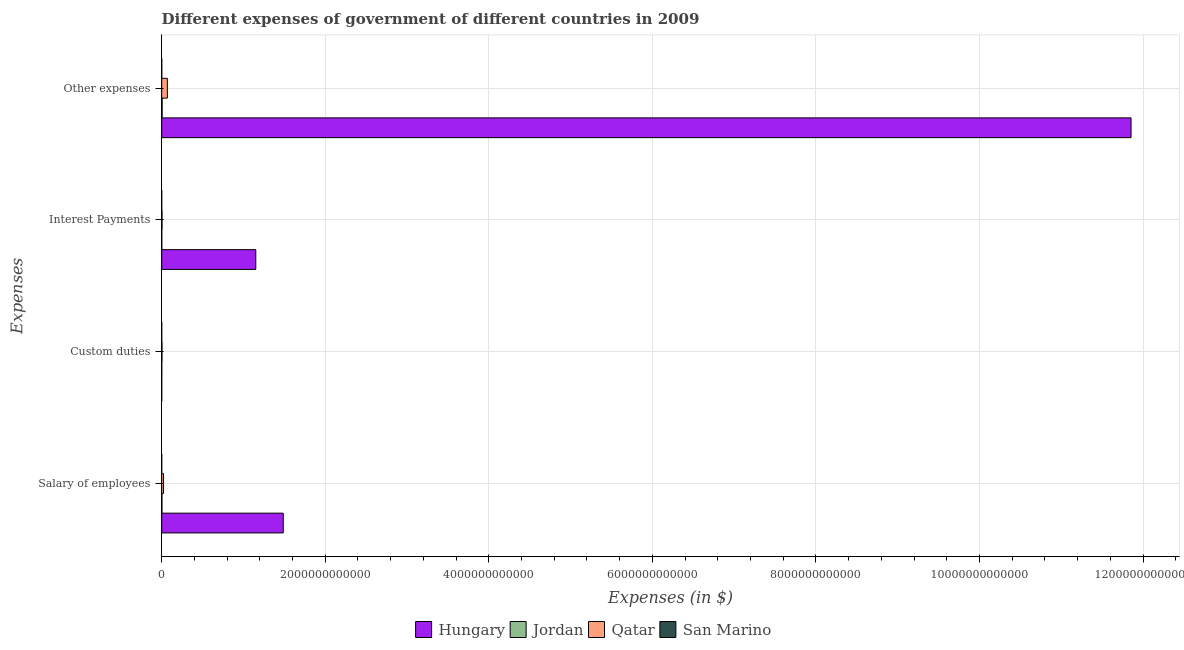How many groups of bars are there?
Provide a short and direct response. 4. How many bars are there on the 4th tick from the top?
Ensure brevity in your answer.  4. What is the label of the 1st group of bars from the top?
Your response must be concise. Other expenses. What is the amount spent on custom duties in Jordan?
Your answer should be very brief. 2.70e+08. Across all countries, what is the maximum amount spent on interest payments?
Your answer should be very brief. 1.15e+12. Across all countries, what is the minimum amount spent on other expenses?
Offer a terse response. 5.34e+08. In which country was the amount spent on interest payments maximum?
Offer a terse response. Hungary. What is the total amount spent on interest payments in the graph?
Your response must be concise. 1.15e+12. What is the difference between the amount spent on salary of employees in San Marino and that in Jordan?
Your answer should be very brief. -2.36e+09. What is the difference between the amount spent on custom duties in San Marino and the amount spent on other expenses in Hungary?
Give a very brief answer. -1.19e+13. What is the average amount spent on other expenses per country?
Your answer should be compact. 2.98e+12. What is the difference between the amount spent on custom duties and amount spent on interest payments in San Marino?
Your answer should be very brief. -2.53e+06. What is the ratio of the amount spent on other expenses in Qatar to that in San Marino?
Your answer should be very brief. 129.28. Is the difference between the amount spent on interest payments in Jordan and San Marino greater than the difference between the amount spent on salary of employees in Jordan and San Marino?
Give a very brief answer. No. What is the difference between the highest and the second highest amount spent on custom duties?
Provide a succinct answer. 2.84e+09. What is the difference between the highest and the lowest amount spent on interest payments?
Your answer should be very brief. 1.15e+12. In how many countries, is the amount spent on other expenses greater than the average amount spent on other expenses taken over all countries?
Offer a terse response. 1. Is it the case that in every country, the sum of the amount spent on salary of employees and amount spent on custom duties is greater than the amount spent on interest payments?
Offer a very short reply. Yes. Are all the bars in the graph horizontal?
Provide a succinct answer. Yes. What is the difference between two consecutive major ticks on the X-axis?
Provide a succinct answer. 2.00e+12. Does the graph contain grids?
Your response must be concise. Yes. Where does the legend appear in the graph?
Give a very brief answer. Bottom center. How many legend labels are there?
Provide a short and direct response. 4. What is the title of the graph?
Provide a succinct answer. Different expenses of government of different countries in 2009. Does "Lebanon" appear as one of the legend labels in the graph?
Keep it short and to the point. No. What is the label or title of the X-axis?
Your answer should be compact. Expenses (in $). What is the label or title of the Y-axis?
Give a very brief answer. Expenses. What is the Expenses (in $) of Hungary in Salary of employees?
Provide a short and direct response. 1.49e+12. What is the Expenses (in $) of Jordan in Salary of employees?
Give a very brief answer. 2.53e+09. What is the Expenses (in $) in Qatar in Salary of employees?
Ensure brevity in your answer.  2.24e+1. What is the Expenses (in $) of San Marino in Salary of employees?
Ensure brevity in your answer.  1.77e+08. What is the Expenses (in $) in Hungary in Custom duties?
Make the answer very short. 0. What is the Expenses (in $) of Jordan in Custom duties?
Make the answer very short. 2.70e+08. What is the Expenses (in $) of Qatar in Custom duties?
Offer a terse response. 3.11e+09. What is the Expenses (in $) of San Marino in Custom duties?
Offer a terse response. 3.91e+06. What is the Expenses (in $) in Hungary in Interest Payments?
Your answer should be compact. 1.15e+12. What is the Expenses (in $) in Jordan in Interest Payments?
Provide a short and direct response. 3.92e+08. What is the Expenses (in $) of Qatar in Interest Payments?
Keep it short and to the point. 3.60e+09. What is the Expenses (in $) in San Marino in Interest Payments?
Provide a short and direct response. 6.45e+06. What is the Expenses (in $) of Hungary in Other expenses?
Your response must be concise. 1.19e+13. What is the Expenses (in $) in Jordan in Other expenses?
Provide a short and direct response. 5.09e+09. What is the Expenses (in $) in Qatar in Other expenses?
Your answer should be compact. 6.90e+1. What is the Expenses (in $) of San Marino in Other expenses?
Your answer should be very brief. 5.34e+08. Across all Expenses, what is the maximum Expenses (in $) in Hungary?
Offer a very short reply. 1.19e+13. Across all Expenses, what is the maximum Expenses (in $) of Jordan?
Make the answer very short. 5.09e+09. Across all Expenses, what is the maximum Expenses (in $) of Qatar?
Provide a short and direct response. 6.90e+1. Across all Expenses, what is the maximum Expenses (in $) in San Marino?
Your answer should be compact. 5.34e+08. Across all Expenses, what is the minimum Expenses (in $) in Jordan?
Your answer should be very brief. 2.70e+08. Across all Expenses, what is the minimum Expenses (in $) in Qatar?
Provide a short and direct response. 3.11e+09. Across all Expenses, what is the minimum Expenses (in $) in San Marino?
Provide a succinct answer. 3.91e+06. What is the total Expenses (in $) in Hungary in the graph?
Make the answer very short. 1.45e+13. What is the total Expenses (in $) in Jordan in the graph?
Offer a terse response. 8.29e+09. What is the total Expenses (in $) in Qatar in the graph?
Make the answer very short. 9.81e+1. What is the total Expenses (in $) in San Marino in the graph?
Offer a very short reply. 7.21e+08. What is the difference between the Expenses (in $) of Jordan in Salary of employees and that in Custom duties?
Offer a very short reply. 2.26e+09. What is the difference between the Expenses (in $) in Qatar in Salary of employees and that in Custom duties?
Keep it short and to the point. 1.93e+1. What is the difference between the Expenses (in $) of San Marino in Salary of employees and that in Custom duties?
Keep it short and to the point. 1.73e+08. What is the difference between the Expenses (in $) in Hungary in Salary of employees and that in Interest Payments?
Your response must be concise. 3.35e+11. What is the difference between the Expenses (in $) of Jordan in Salary of employees and that in Interest Payments?
Your answer should be compact. 2.14e+09. What is the difference between the Expenses (in $) in Qatar in Salary of employees and that in Interest Payments?
Give a very brief answer. 1.88e+1. What is the difference between the Expenses (in $) in San Marino in Salary of employees and that in Interest Payments?
Ensure brevity in your answer.  1.71e+08. What is the difference between the Expenses (in $) of Hungary in Salary of employees and that in Other expenses?
Your answer should be compact. -1.04e+13. What is the difference between the Expenses (in $) in Jordan in Salary of employees and that in Other expenses?
Ensure brevity in your answer.  -2.56e+09. What is the difference between the Expenses (in $) in Qatar in Salary of employees and that in Other expenses?
Offer a very short reply. -4.66e+1. What is the difference between the Expenses (in $) in San Marino in Salary of employees and that in Other expenses?
Keep it short and to the point. -3.57e+08. What is the difference between the Expenses (in $) in Jordan in Custom duties and that in Interest Payments?
Provide a succinct answer. -1.22e+08. What is the difference between the Expenses (in $) of Qatar in Custom duties and that in Interest Payments?
Offer a terse response. -4.85e+08. What is the difference between the Expenses (in $) of San Marino in Custom duties and that in Interest Payments?
Make the answer very short. -2.53e+06. What is the difference between the Expenses (in $) in Jordan in Custom duties and that in Other expenses?
Provide a short and direct response. -4.82e+09. What is the difference between the Expenses (in $) of Qatar in Custom duties and that in Other expenses?
Keep it short and to the point. -6.59e+1. What is the difference between the Expenses (in $) of San Marino in Custom duties and that in Other expenses?
Make the answer very short. -5.30e+08. What is the difference between the Expenses (in $) of Hungary in Interest Payments and that in Other expenses?
Your response must be concise. -1.07e+13. What is the difference between the Expenses (in $) of Jordan in Interest Payments and that in Other expenses?
Offer a terse response. -4.70e+09. What is the difference between the Expenses (in $) of Qatar in Interest Payments and that in Other expenses?
Your response must be concise. -6.54e+1. What is the difference between the Expenses (in $) in San Marino in Interest Payments and that in Other expenses?
Ensure brevity in your answer.  -5.27e+08. What is the difference between the Expenses (in $) of Hungary in Salary of employees and the Expenses (in $) of Jordan in Custom duties?
Your answer should be compact. 1.49e+12. What is the difference between the Expenses (in $) in Hungary in Salary of employees and the Expenses (in $) in Qatar in Custom duties?
Offer a very short reply. 1.48e+12. What is the difference between the Expenses (in $) of Hungary in Salary of employees and the Expenses (in $) of San Marino in Custom duties?
Your answer should be compact. 1.49e+12. What is the difference between the Expenses (in $) in Jordan in Salary of employees and the Expenses (in $) in Qatar in Custom duties?
Ensure brevity in your answer.  -5.81e+08. What is the difference between the Expenses (in $) in Jordan in Salary of employees and the Expenses (in $) in San Marino in Custom duties?
Give a very brief answer. 2.53e+09. What is the difference between the Expenses (in $) of Qatar in Salary of employees and the Expenses (in $) of San Marino in Custom duties?
Give a very brief answer. 2.24e+1. What is the difference between the Expenses (in $) in Hungary in Salary of employees and the Expenses (in $) in Jordan in Interest Payments?
Keep it short and to the point. 1.49e+12. What is the difference between the Expenses (in $) in Hungary in Salary of employees and the Expenses (in $) in Qatar in Interest Payments?
Your answer should be very brief. 1.48e+12. What is the difference between the Expenses (in $) of Hungary in Salary of employees and the Expenses (in $) of San Marino in Interest Payments?
Offer a terse response. 1.49e+12. What is the difference between the Expenses (in $) of Jordan in Salary of employees and the Expenses (in $) of Qatar in Interest Payments?
Keep it short and to the point. -1.07e+09. What is the difference between the Expenses (in $) in Jordan in Salary of employees and the Expenses (in $) in San Marino in Interest Payments?
Your answer should be very brief. 2.53e+09. What is the difference between the Expenses (in $) of Qatar in Salary of employees and the Expenses (in $) of San Marino in Interest Payments?
Keep it short and to the point. 2.24e+1. What is the difference between the Expenses (in $) of Hungary in Salary of employees and the Expenses (in $) of Jordan in Other expenses?
Your response must be concise. 1.48e+12. What is the difference between the Expenses (in $) of Hungary in Salary of employees and the Expenses (in $) of Qatar in Other expenses?
Your answer should be very brief. 1.42e+12. What is the difference between the Expenses (in $) of Hungary in Salary of employees and the Expenses (in $) of San Marino in Other expenses?
Keep it short and to the point. 1.49e+12. What is the difference between the Expenses (in $) of Jordan in Salary of employees and the Expenses (in $) of Qatar in Other expenses?
Give a very brief answer. -6.65e+1. What is the difference between the Expenses (in $) in Jordan in Salary of employees and the Expenses (in $) in San Marino in Other expenses?
Your response must be concise. 2.00e+09. What is the difference between the Expenses (in $) in Qatar in Salary of employees and the Expenses (in $) in San Marino in Other expenses?
Offer a very short reply. 2.18e+1. What is the difference between the Expenses (in $) in Jordan in Custom duties and the Expenses (in $) in Qatar in Interest Payments?
Offer a terse response. -3.33e+09. What is the difference between the Expenses (in $) in Jordan in Custom duties and the Expenses (in $) in San Marino in Interest Payments?
Make the answer very short. 2.64e+08. What is the difference between the Expenses (in $) of Qatar in Custom duties and the Expenses (in $) of San Marino in Interest Payments?
Ensure brevity in your answer.  3.11e+09. What is the difference between the Expenses (in $) in Jordan in Custom duties and the Expenses (in $) in Qatar in Other expenses?
Your answer should be compact. -6.87e+1. What is the difference between the Expenses (in $) in Jordan in Custom duties and the Expenses (in $) in San Marino in Other expenses?
Keep it short and to the point. -2.64e+08. What is the difference between the Expenses (in $) in Qatar in Custom duties and the Expenses (in $) in San Marino in Other expenses?
Provide a succinct answer. 2.58e+09. What is the difference between the Expenses (in $) in Hungary in Interest Payments and the Expenses (in $) in Jordan in Other expenses?
Ensure brevity in your answer.  1.15e+12. What is the difference between the Expenses (in $) in Hungary in Interest Payments and the Expenses (in $) in Qatar in Other expenses?
Keep it short and to the point. 1.08e+12. What is the difference between the Expenses (in $) in Hungary in Interest Payments and the Expenses (in $) in San Marino in Other expenses?
Keep it short and to the point. 1.15e+12. What is the difference between the Expenses (in $) in Jordan in Interest Payments and the Expenses (in $) in Qatar in Other expenses?
Your answer should be very brief. -6.86e+1. What is the difference between the Expenses (in $) of Jordan in Interest Payments and the Expenses (in $) of San Marino in Other expenses?
Offer a terse response. -1.42e+08. What is the difference between the Expenses (in $) in Qatar in Interest Payments and the Expenses (in $) in San Marino in Other expenses?
Ensure brevity in your answer.  3.07e+09. What is the average Expenses (in $) in Hungary per Expenses?
Your response must be concise. 3.62e+12. What is the average Expenses (in $) in Jordan per Expenses?
Provide a succinct answer. 2.07e+09. What is the average Expenses (in $) in Qatar per Expenses?
Ensure brevity in your answer.  2.45e+1. What is the average Expenses (in $) in San Marino per Expenses?
Give a very brief answer. 1.80e+08. What is the difference between the Expenses (in $) in Hungary and Expenses (in $) in Jordan in Salary of employees?
Provide a succinct answer. 1.48e+12. What is the difference between the Expenses (in $) in Hungary and Expenses (in $) in Qatar in Salary of employees?
Keep it short and to the point. 1.46e+12. What is the difference between the Expenses (in $) of Hungary and Expenses (in $) of San Marino in Salary of employees?
Offer a terse response. 1.49e+12. What is the difference between the Expenses (in $) in Jordan and Expenses (in $) in Qatar in Salary of employees?
Your answer should be very brief. -1.99e+1. What is the difference between the Expenses (in $) of Jordan and Expenses (in $) of San Marino in Salary of employees?
Offer a very short reply. 2.36e+09. What is the difference between the Expenses (in $) of Qatar and Expenses (in $) of San Marino in Salary of employees?
Your answer should be compact. 2.22e+1. What is the difference between the Expenses (in $) of Jordan and Expenses (in $) of Qatar in Custom duties?
Offer a very short reply. -2.84e+09. What is the difference between the Expenses (in $) in Jordan and Expenses (in $) in San Marino in Custom duties?
Keep it short and to the point. 2.66e+08. What is the difference between the Expenses (in $) of Qatar and Expenses (in $) of San Marino in Custom duties?
Keep it short and to the point. 3.11e+09. What is the difference between the Expenses (in $) of Hungary and Expenses (in $) of Jordan in Interest Payments?
Provide a succinct answer. 1.15e+12. What is the difference between the Expenses (in $) in Hungary and Expenses (in $) in Qatar in Interest Payments?
Offer a terse response. 1.15e+12. What is the difference between the Expenses (in $) in Hungary and Expenses (in $) in San Marino in Interest Payments?
Keep it short and to the point. 1.15e+12. What is the difference between the Expenses (in $) in Jordan and Expenses (in $) in Qatar in Interest Payments?
Offer a terse response. -3.21e+09. What is the difference between the Expenses (in $) in Jordan and Expenses (in $) in San Marino in Interest Payments?
Your response must be concise. 3.86e+08. What is the difference between the Expenses (in $) of Qatar and Expenses (in $) of San Marino in Interest Payments?
Your response must be concise. 3.59e+09. What is the difference between the Expenses (in $) of Hungary and Expenses (in $) of Jordan in Other expenses?
Make the answer very short. 1.18e+13. What is the difference between the Expenses (in $) in Hungary and Expenses (in $) in Qatar in Other expenses?
Offer a very short reply. 1.18e+13. What is the difference between the Expenses (in $) of Hungary and Expenses (in $) of San Marino in Other expenses?
Keep it short and to the point. 1.19e+13. What is the difference between the Expenses (in $) in Jordan and Expenses (in $) in Qatar in Other expenses?
Your answer should be very brief. -6.39e+1. What is the difference between the Expenses (in $) of Jordan and Expenses (in $) of San Marino in Other expenses?
Your response must be concise. 4.56e+09. What is the difference between the Expenses (in $) in Qatar and Expenses (in $) in San Marino in Other expenses?
Provide a succinct answer. 6.85e+1. What is the ratio of the Expenses (in $) in Jordan in Salary of employees to that in Custom duties?
Your response must be concise. 9.37. What is the ratio of the Expenses (in $) in Qatar in Salary of employees to that in Custom duties?
Ensure brevity in your answer.  7.19. What is the ratio of the Expenses (in $) of San Marino in Salary of employees to that in Custom duties?
Offer a terse response. 45.28. What is the ratio of the Expenses (in $) in Hungary in Salary of employees to that in Interest Payments?
Offer a very short reply. 1.29. What is the ratio of the Expenses (in $) of Jordan in Salary of employees to that in Interest Payments?
Offer a terse response. 6.46. What is the ratio of the Expenses (in $) of Qatar in Salary of employees to that in Interest Payments?
Your answer should be very brief. 6.22. What is the ratio of the Expenses (in $) of San Marino in Salary of employees to that in Interest Payments?
Offer a very short reply. 27.49. What is the ratio of the Expenses (in $) of Hungary in Salary of employees to that in Other expenses?
Your answer should be compact. 0.13. What is the ratio of the Expenses (in $) in Jordan in Salary of employees to that in Other expenses?
Ensure brevity in your answer.  0.5. What is the ratio of the Expenses (in $) in Qatar in Salary of employees to that in Other expenses?
Provide a succinct answer. 0.32. What is the ratio of the Expenses (in $) of San Marino in Salary of employees to that in Other expenses?
Provide a short and direct response. 0.33. What is the ratio of the Expenses (in $) of Jordan in Custom duties to that in Interest Payments?
Make the answer very short. 0.69. What is the ratio of the Expenses (in $) in Qatar in Custom duties to that in Interest Payments?
Provide a succinct answer. 0.87. What is the ratio of the Expenses (in $) in San Marino in Custom duties to that in Interest Payments?
Ensure brevity in your answer.  0.61. What is the ratio of the Expenses (in $) of Jordan in Custom duties to that in Other expenses?
Your response must be concise. 0.05. What is the ratio of the Expenses (in $) in Qatar in Custom duties to that in Other expenses?
Your answer should be compact. 0.05. What is the ratio of the Expenses (in $) in San Marino in Custom duties to that in Other expenses?
Your response must be concise. 0.01. What is the ratio of the Expenses (in $) in Hungary in Interest Payments to that in Other expenses?
Your answer should be compact. 0.1. What is the ratio of the Expenses (in $) in Jordan in Interest Payments to that in Other expenses?
Offer a terse response. 0.08. What is the ratio of the Expenses (in $) in Qatar in Interest Payments to that in Other expenses?
Your response must be concise. 0.05. What is the ratio of the Expenses (in $) of San Marino in Interest Payments to that in Other expenses?
Provide a succinct answer. 0.01. What is the difference between the highest and the second highest Expenses (in $) in Hungary?
Offer a very short reply. 1.04e+13. What is the difference between the highest and the second highest Expenses (in $) in Jordan?
Make the answer very short. 2.56e+09. What is the difference between the highest and the second highest Expenses (in $) of Qatar?
Your answer should be compact. 4.66e+1. What is the difference between the highest and the second highest Expenses (in $) in San Marino?
Offer a very short reply. 3.57e+08. What is the difference between the highest and the lowest Expenses (in $) in Hungary?
Offer a very short reply. 1.19e+13. What is the difference between the highest and the lowest Expenses (in $) of Jordan?
Your answer should be compact. 4.82e+09. What is the difference between the highest and the lowest Expenses (in $) in Qatar?
Offer a terse response. 6.59e+1. What is the difference between the highest and the lowest Expenses (in $) in San Marino?
Your response must be concise. 5.30e+08. 